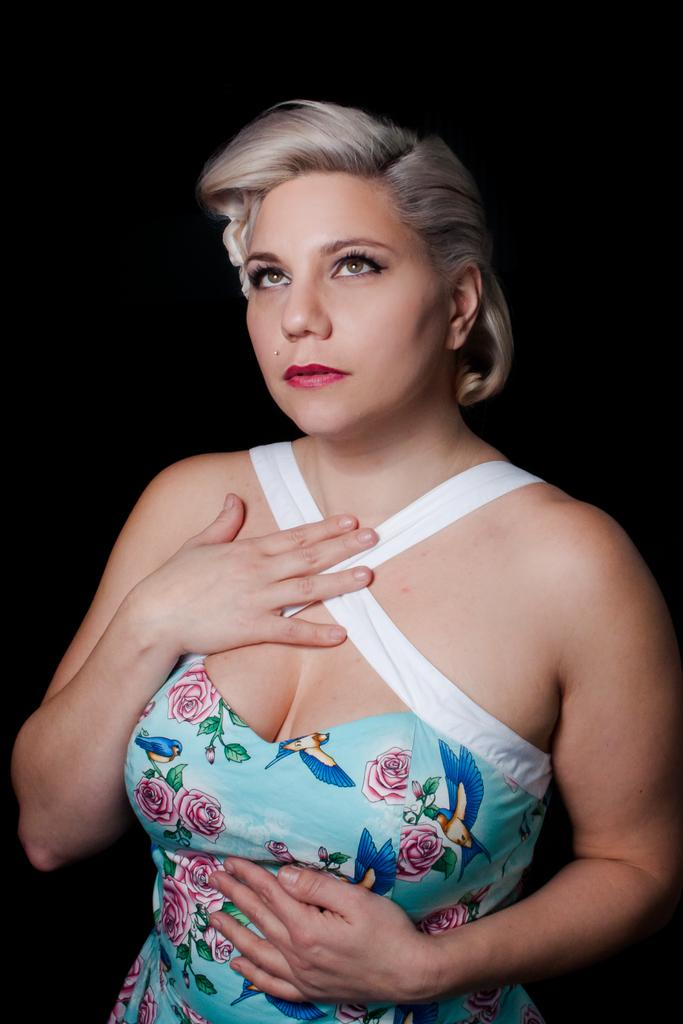Who is the main subject in the image? There is a woman in the image. What can be observed about the background of the image? The background of the image is dark. What is the crook's reason for stealing the owner's property in the image? There is no crook or theft depicted in the image; it features a woman with a dark background. 